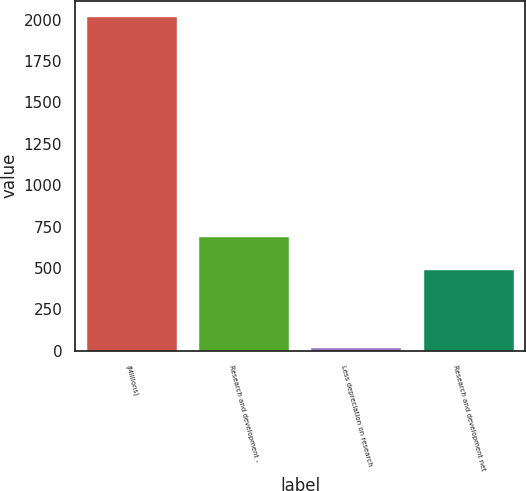Convert chart to OTSL. <chart><loc_0><loc_0><loc_500><loc_500><bar_chart><fcel>(Millions)<fcel>Research and development -<fcel>Less depreciation on research<fcel>Research and development net<nl><fcel>2013<fcel>687.6<fcel>17<fcel>488<nl></chart> 